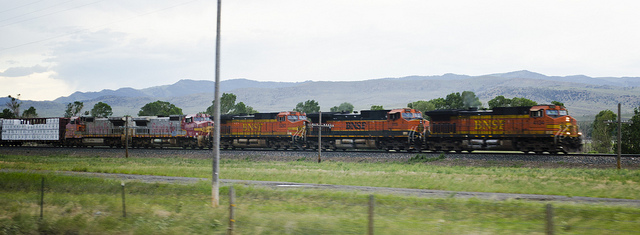Please transcribe the text in this image. BNSE BNSE BNSE BNSE BNSE 